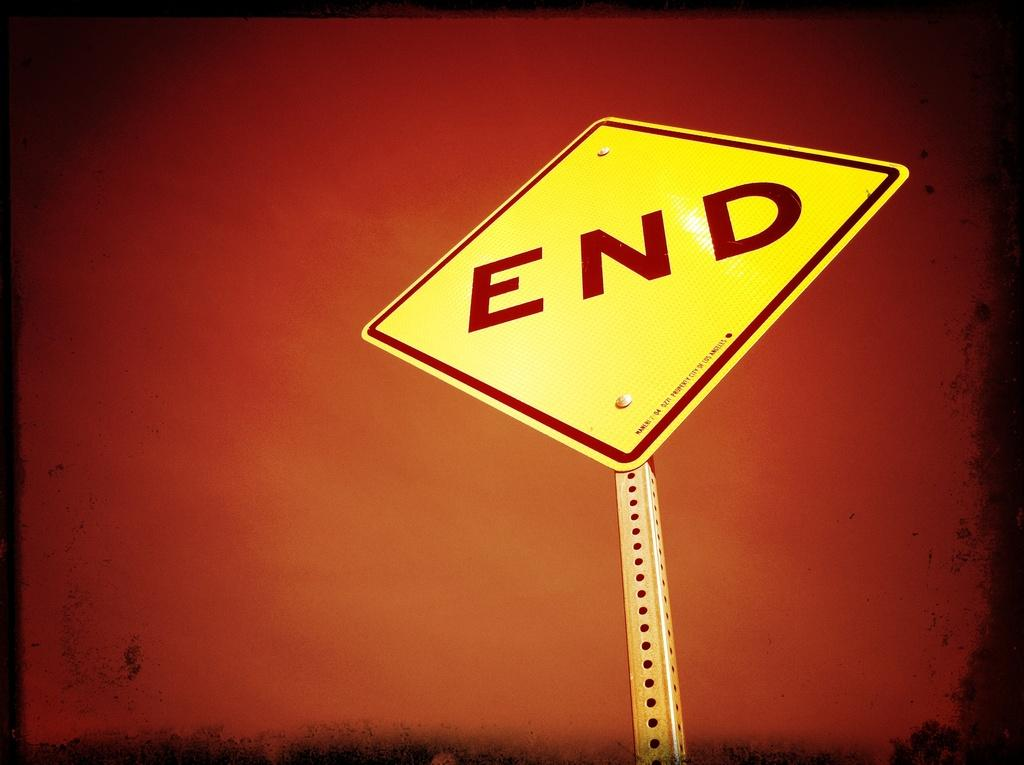<image>
Present a compact description of the photo's key features. A yellow sign saying END is shown on a reddish faded dark background. 